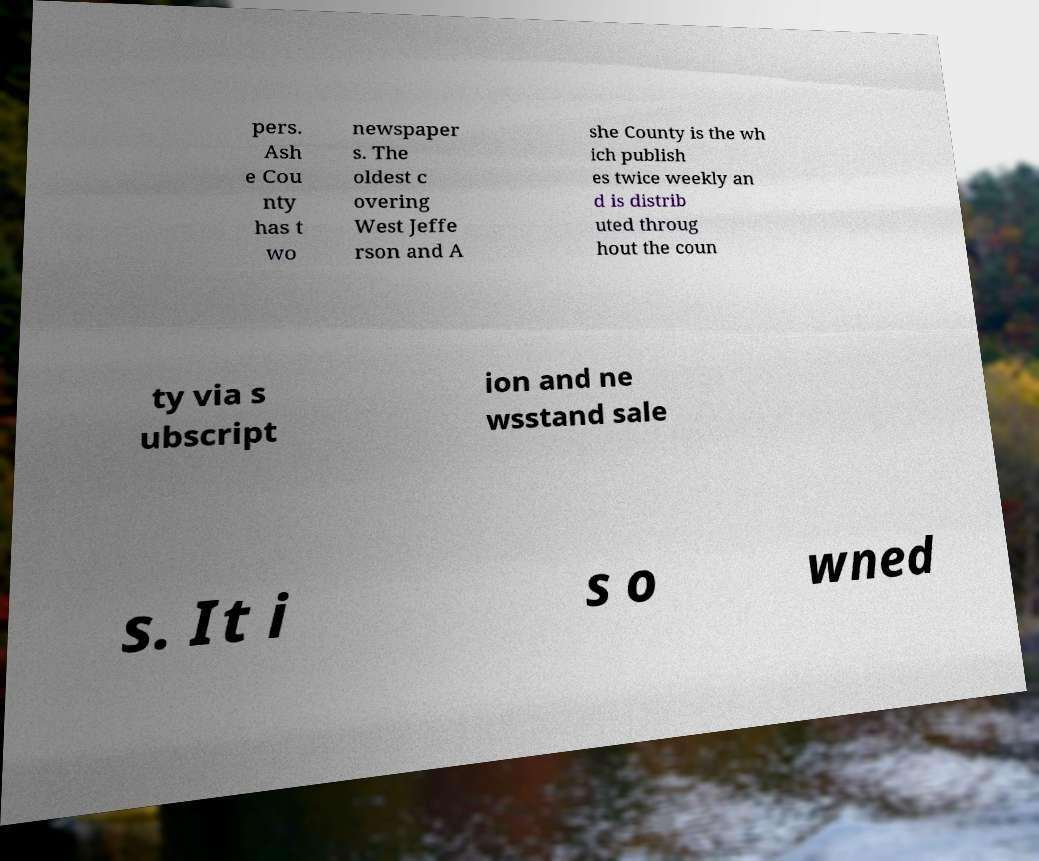Please identify and transcribe the text found in this image. pers. Ash e Cou nty has t wo newspaper s. The oldest c overing West Jeffe rson and A she County is the wh ich publish es twice weekly an d is distrib uted throug hout the coun ty via s ubscript ion and ne wsstand sale s. It i s o wned 